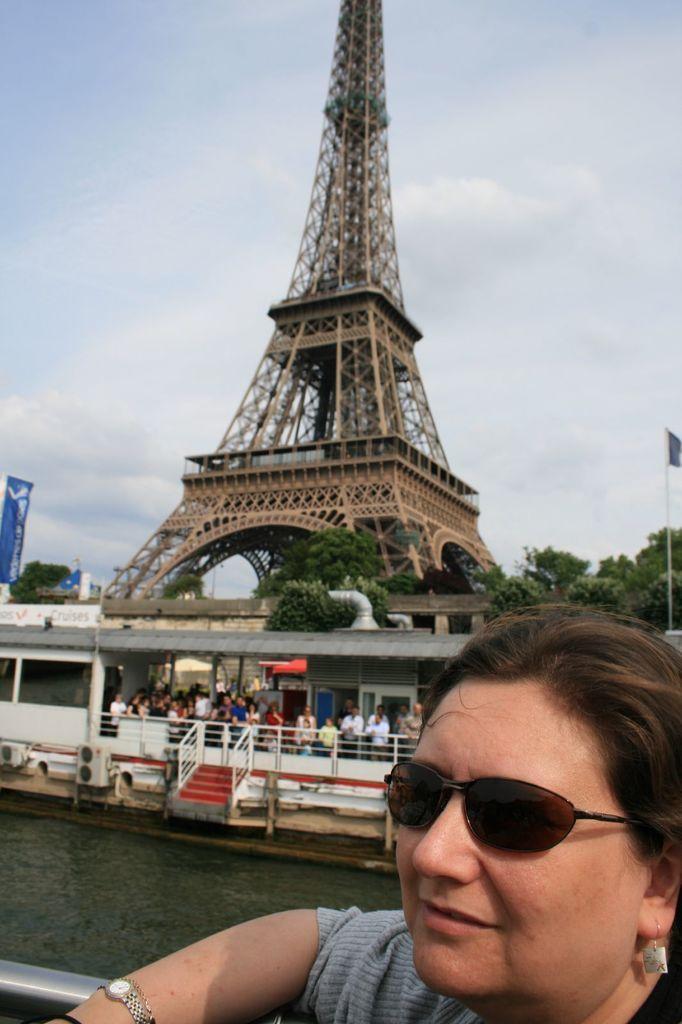In one or two sentences, can you explain what this image depicts? In this picture I can see a tower and few trees and I can see few people are standing and a woman wearing sunglasses and I can see a banner with some text and a cloudy sky. 